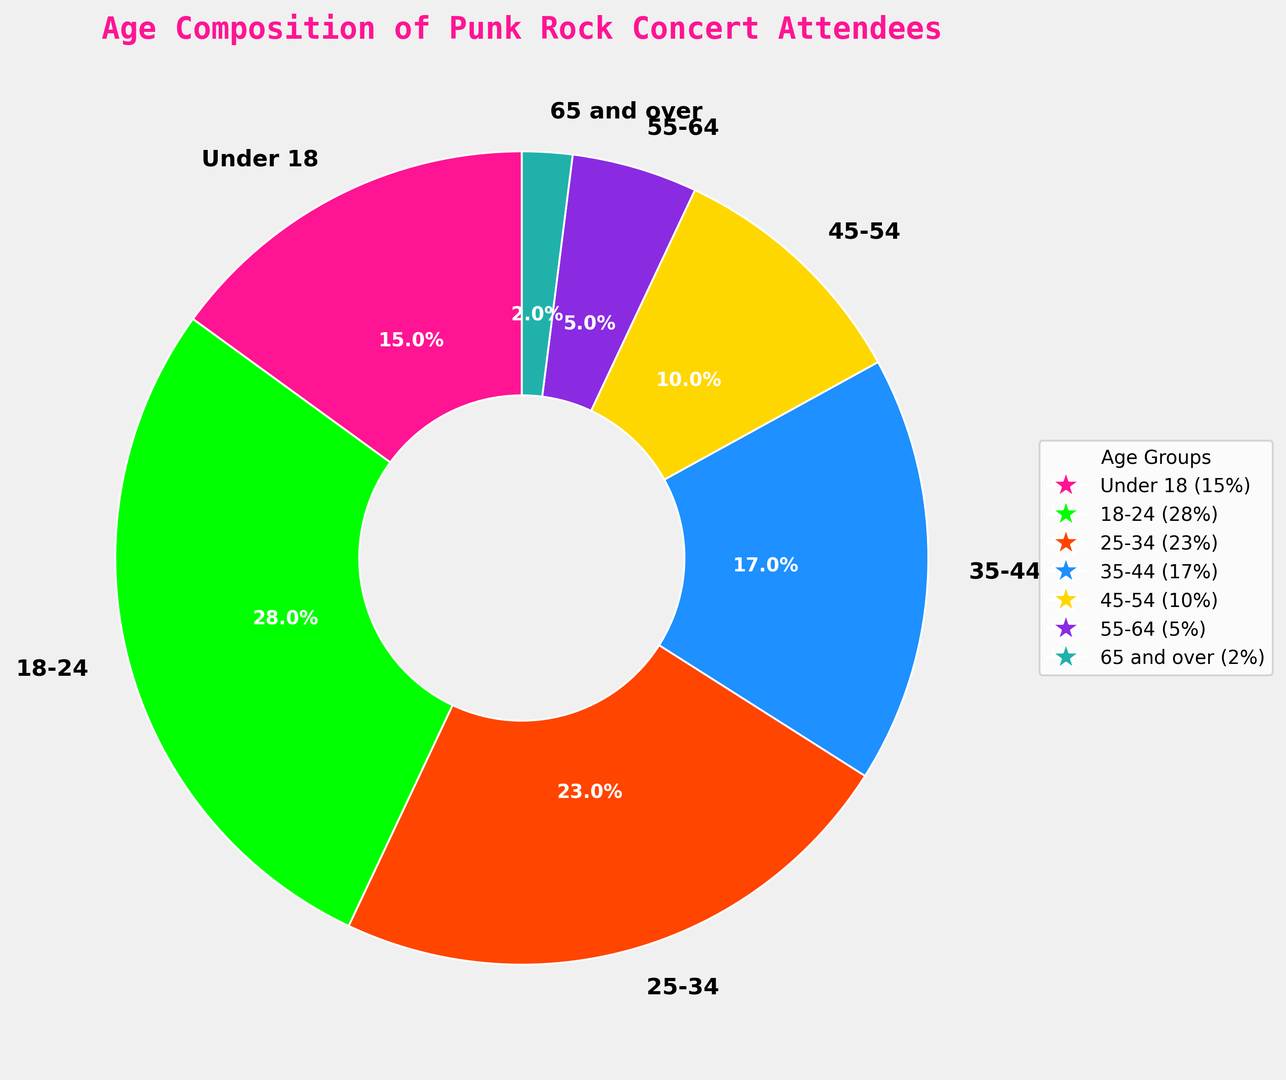How many percentage points more attendees are there in the 18-24 age group compared to the 45-54 age group? Subtract the percentage of the 45-54 age group (10%) from the percentage of the 18-24 age group (28%). 28% - 10% = 18%.
Answer: 18% Which age group has the largest representation at punk rock concerts? Observe the age group with the highest percentage on the pie chart. The 18-24 age group has the highest value at 28%.
Answer: 18-24 What is the combined percentage of attendees aged 25-44? Add the percentages of the 25-34 age group (23%) and the 35-44 age group (17%). 23% + 17% = 40%.
Answer: 40% Which age group has the smallest representation, and what percentage do they hold? Identify the age group with the smallest percentage in the pie chart. The 65 and over group has the smallest representation at 2%.
Answer: 65 and over, 2% How much more represented is the 18-24 age group compared to the 55-64 age group? Subtract the percentage of the 55-64 age group (5%) from the percentage of the 18-24 age group (28%). 28% - 5% = 23%.
Answer: 23% Is there a greater percentage of attendees under 18 or attendees aged 55-64? Compare the percentages of the under 18 age group (15%) with the 55-64 age group (5%). 15% is greater than 5%.
Answer: Under 18 What is the difference between the percentage of attendees aged 35-44 and those aged 45-54? Subtract the percentage of the 45-54 age group (10%) from the percentage of the 35-44 age group (17%). 17% - 10% = 7%.
Answer: 7% What is the total percentage of attendees over the age of 44? Add the percentages of the 45-54 (10%), 55-64 (5%), and 65 and over (2%) age groups. 10% + 5% + 2% = 17%.
Answer: 17% Which age groups are represented with more than 20% of the total attendees each? Identify the age groups with percentages over 20%. The 18-24 (28%) and 25-34 (23%) age groups meet this criterion.
Answer: 18-24, 25-34 What is the percentage difference between the 25-34 age group and the under 18 age group? Subtract the percentage of the under 18 age group (15%) from the percentage of the 25-34 age group (23%). 23% - 15% = 8%.
Answer: 8% 